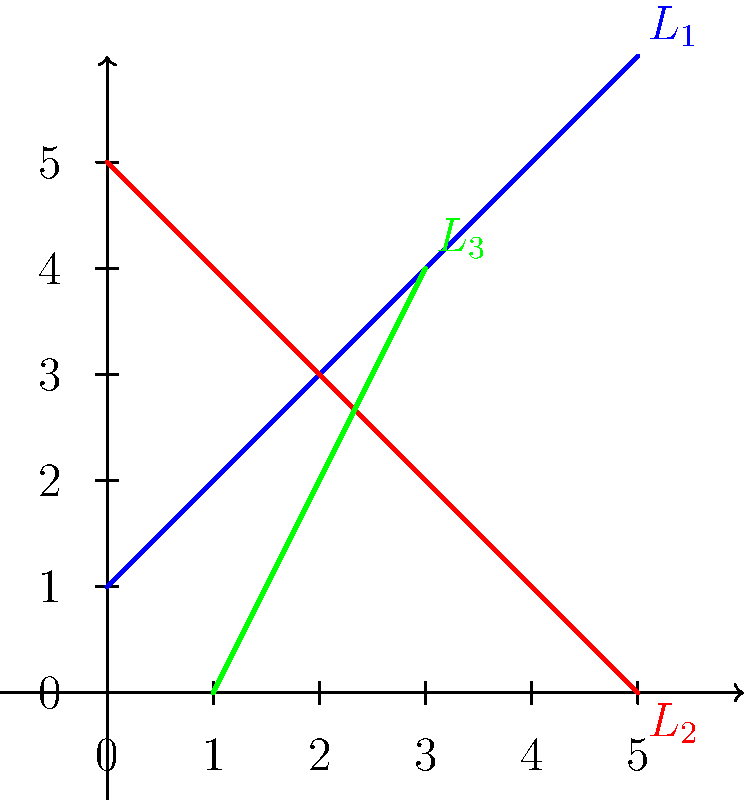In the coordinate plane above, three lines represent different aspects of a social cause: $L_1$ (blue) represents the main challenges, $L_2$ (red) represents opposition, and $L_3$ (green) represents support. Which pair of lines are perpendicular to each other, symbolizing the direct confrontation between two aspects of the cause? To determine which pair of lines are perpendicular, we need to calculate their slopes and check if they are negative reciprocals of each other. Let's find the slopes of each line:

1. For $L_1$ (blue):
   Slope $m_1 = \frac{6-1}{5-0} = 1$

2. For $L_2$ (red):
   Slope $m_2 = \frac{0-5}{5-0} = -1$

3. For $L_3$ (green):
   Slope $m_3 = \frac{4-0}{3-1} = 2$

Perpendicular lines have slopes that are negative reciprocals of each other. We can see that:

$m_1 \cdot m_2 = 1 \cdot (-1) = -1$

This means that $L_1$ and $L_2$ are perpendicular to each other.

The slopes of $L_1$ and $L_3$, and $L_2$ and $L_3$ do not satisfy this condition, so they are not perpendicular.

Therefore, the blue line ($L_1$) representing the main challenges and the red line ($L_2$) representing opposition are perpendicular, symbolizing the direct confrontation between these two aspects of the cause.
Answer: $L_1$ and $L_2$ 